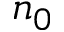<formula> <loc_0><loc_0><loc_500><loc_500>n _ { 0 }</formula> 